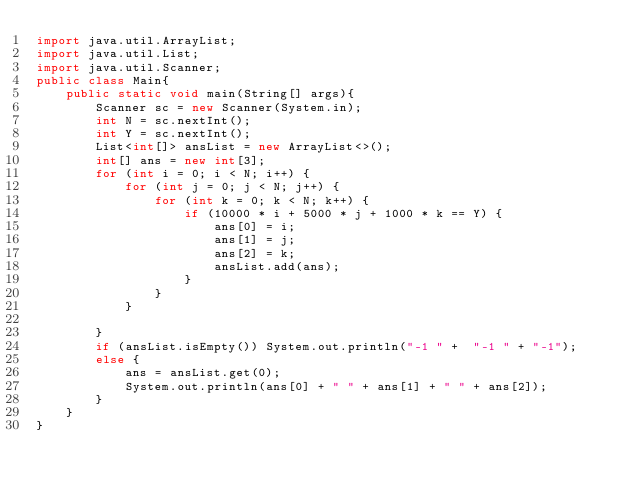<code> <loc_0><loc_0><loc_500><loc_500><_Java_>import java.util.ArrayList;
import java.util.List;
import java.util.Scanner;
public class Main{
	public static void main(String[] args){
		Scanner sc = new Scanner(System.in);
		int N = sc.nextInt();
		int Y = sc.nextInt();
		List<int[]> ansList = new ArrayList<>();
		int[] ans = new int[3];
		for (int i = 0; i < N; i++) {
			for (int j = 0; j < N; j++) {
				for (int k = 0; k < N; k++) {
					if (10000 * i + 5000 * j + 1000 * k == Y) {
						ans[0] = i;
						ans[1] = j;
						ans[2] = k;
						ansList.add(ans);
					}
				}
			}
			
		}
		if (ansList.isEmpty()) System.out.println("-1 " +  "-1 " + "-1");
		else {
			ans = ansList.get(0);
			System.out.println(ans[0] + " " + ans[1] + " " + ans[2]);
		}
	}
}</code> 